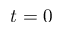Convert formula to latex. <formula><loc_0><loc_0><loc_500><loc_500>t = 0</formula> 